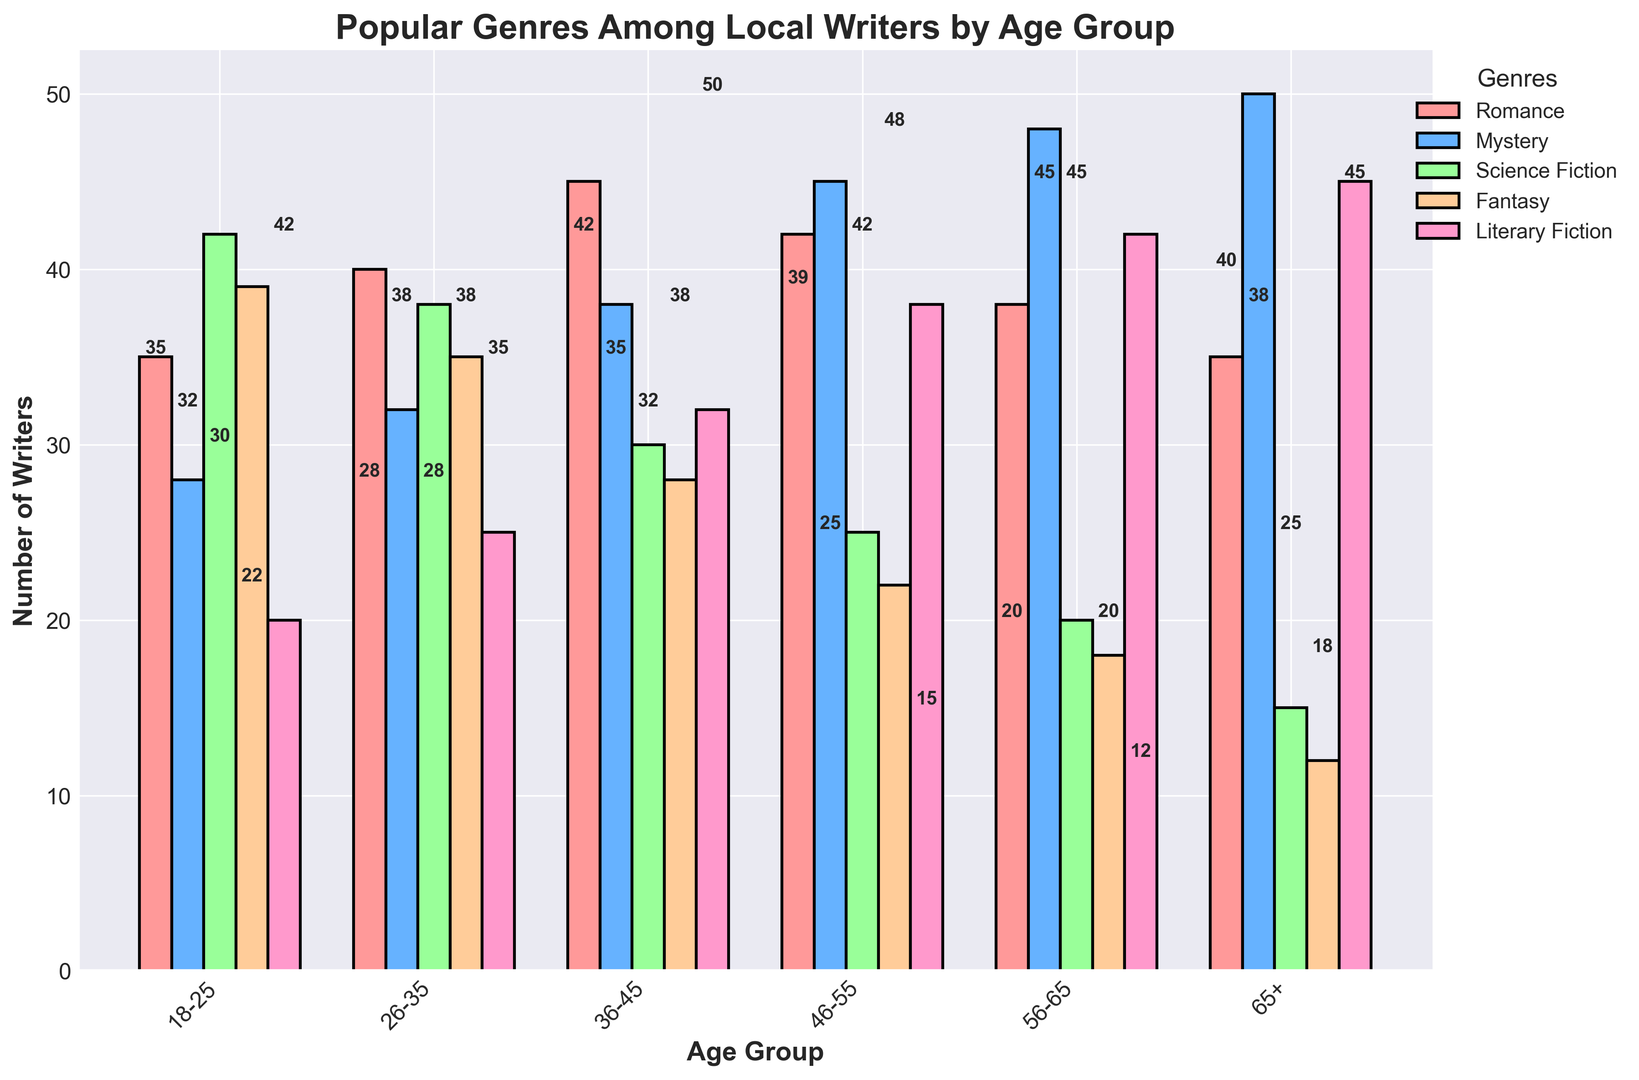What's the most popular genre among the 26-35 age group? The highest bar for the 26-35 age group corresponds to the Romance genre, indicating that it has the maximum value.
Answer: Romance Which age group has the highest number of writers in the Mystery genre? By comparing the heights of the Mystery bars across all age groups, the tallest bar is for the 65+ age group.
Answer: 65+ Is the number of Fantasy writers greater in the 18-25 age group or the 46-55 age group? By comparing the heights of the Fantasy bars, the 18-25 age group has 39 writers, while the 46-55 age group has 22. Thus, the number is greater for the 18-25 age group.
Answer: 18-25 Which genre shows a decline in the number of writers as the age group increases? Observing the trends for each genre: Science Fiction shows a decreasing trend from 42 in the 18-25 age group to 15 in the 65+ age group.
Answer: Science Fiction What is the total number of writers in the 56-65 age group? Summing the number of writers across all genres for the 56-65 age group: 38 (Romance) + 48 (Mystery) + 20 (Science Fiction) + 18 (Fantasy) + 42 (Literary Fiction) = 166.
Answer: 166 How does the number of Literary Fiction writers change across age groups? The values for Literary Fiction are: 18-25 (20), 26-35 (25), 36-45 (32), 46-55 (38), 56-65 (42), 65+ (45). It shows an increasing trend as the age group increases.
Answer: Increasing What is the average number of Mystery writers across all age groups? Summing the number of Mystery writers and dividing by the number of age groups: (28 + 32 + 38 + 45 + 48 + 50) / 6 = 40.17 (approximately).
Answer: 40.17 Which age group has the equal number of Romance and Literary Fiction writers? Comparing values across groups, the 65+ age group has 35 Romance writers and 35 Literary Fiction writers.
Answer: 65+ Which genre has the closest number of writers in the 18-25 and 26-35 age groups? Calculating the differences, Romance has a difference of 5 (40-35), Mystery has 4 (32-28), Science Fiction has 4 (42-38), Fantasy has 4 (39-35), and Literary Fiction has 5 (25-20). Mystery, Science Fiction, and Fantasy all have the smallest difference of 4.
Answer: Mystery, Science Fiction, Fantasy Is the number of Science Fiction writers in the 36-45 age group greater than the combined number of Fantasy writers in the 56-65 and 65+ age groups? There are 30 Science Fiction writers in the 36-45 age group, while the combined number of Fantasy writers in the 56-65 and 65+ age groups is 18 + 12 = 30. Both are equal.
Answer: No 